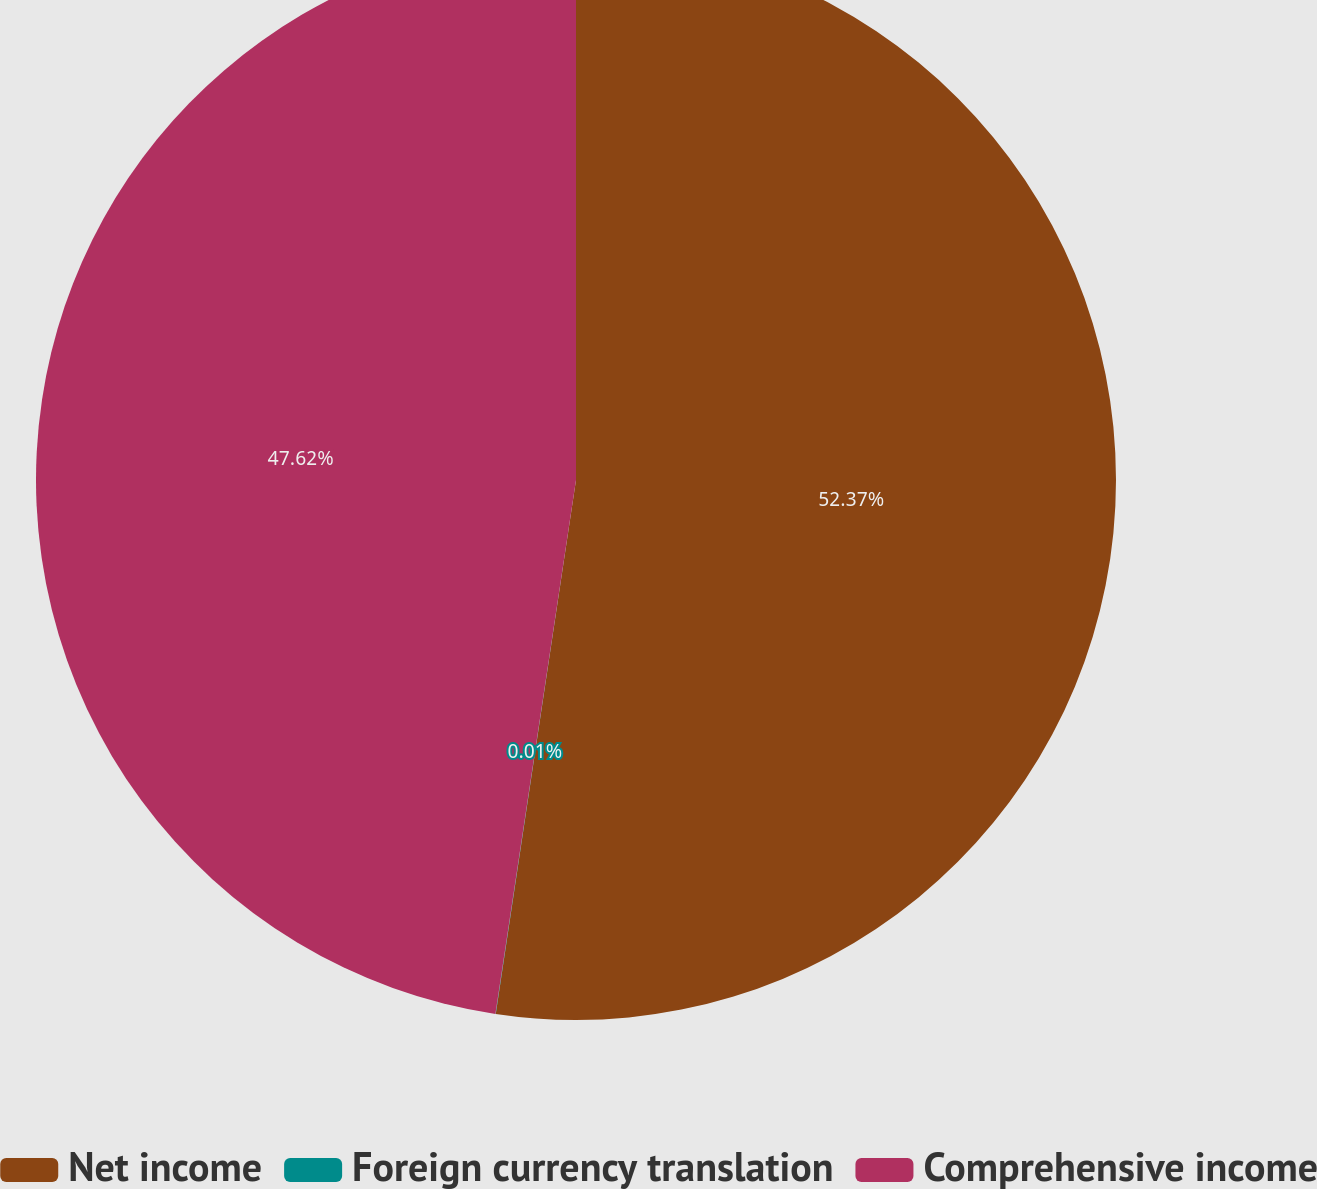Convert chart to OTSL. <chart><loc_0><loc_0><loc_500><loc_500><pie_chart><fcel>Net income<fcel>Foreign currency translation<fcel>Comprehensive income<nl><fcel>52.38%<fcel>0.01%<fcel>47.62%<nl></chart> 